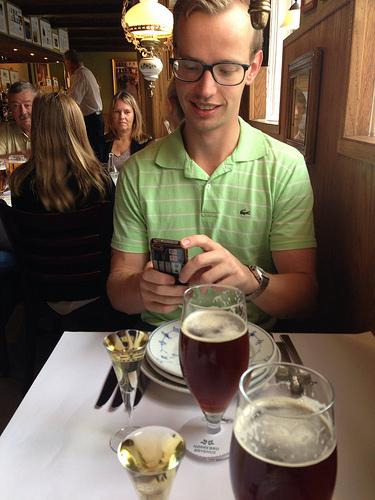Comment on the hair color and length of the woman at the next table. The woman at the next table has blonde, long hair. What is the man holding in his hand? The man is holding a cell phone in his hand. What type of light fixture is present in the image? There is a hanging light fixture in the image. What is the watch on the man's left wrist made of? The watch on the man's left wrist appears to be silver. Identify the type of glasses the man is wearing. The man is wearing black rimmed glasses. How many knives, forks and plates are on the table? There are three butter knives, some silver forks, and circular plates on the table. Describe the type of shirt and its logo the man is wearing. The man is wearing a shirt with a collar and an alligator logo on it. State the color and pattern found on the man's shirt. The man is wearing a green shirt with white stripes. What type of framed object is on the wall? There is a wooden framed picture with a reflection on the wall. Create a description of an object in the image using five adjectives. The gold cup is shiny, round, elegant, reflective, and decorative. Should the table be cleaned after the guests have finished their meal? Yes, since there are plates, silverware, and glasses on the table. Which of the following correctly describes the man's glasses in the image? A) Blue framed glasses B) Black rimmed glasses C) Rimless glasses D) Red framed glasses B) Black rimmed glasses Identify an electronic device present in the image. Cell phone Draw a conclusion about the event happening in the photograph. The man is having a meal at a restaurant or a bar. Is the woman sitting next to the man wearing a bright red dress? The image information does not mention any woman sitting next to the man or the color of her dress. Identify the emotion displayed by the man wearing glasses in the image. Smiling Does the man's shirt have a bright white collar? The image describes the shirt as having a collar, but it doesn't specify the color. Identify the brand logo on the man's shirt. Alligator What is the hair color of the woman sitting at the next table? Blonde Can you see a sparkling gold chandelier hanging from the ceiling? While there is a hanging light fixture, the image does not specify that it is a gold chandelier. Write about something happening in the background of the image. A woman with long blonde hair is sitting at the next table. Is the man's mustache bright pink? The image indicates that the man has a gray mustache. Are there any rainbow-colored balloons on the table? There's no mention of balloons in the image information, just utensils and tablewares. Is the glass on the table full or empty? Full List the utensils on the table. Three butter knives, silver forks, and silver knives Determine if there is a reflection in the picture. Yes, there is a reflection on the picture. Discuss the design seen on the white bowl. The white bowl has blue designs. Describe the details of the lamp in the picture. The lamp is hanging from the ceiling and appears to be a light fixture. Does the man have a colorful tattoo on his forearm? The image information does not mention anything about tattoos on the man's body. What is the color of the man's shirt in the image? Green Describe the appearance of the man’s facial hair. He has a gray mustache. Visualize the clock's location on the image. On the man's left wrist Describe the scene where the man is sitting. The man is sitting at a table with plates, silverware, and glasses. He is wearing black rimmed glasses, a green shirt, and a silver watch while holding a cell phone. There is a hanging light fixture, a wooden frame on the wall, and a mirror nearby. What type of alcoholic beverages are present in the image? wine and beer 